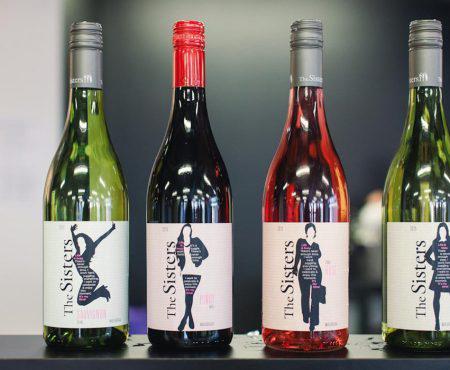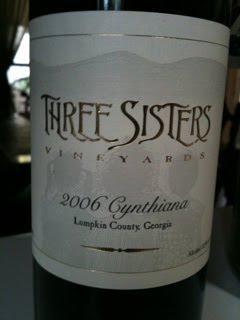The first image is the image on the left, the second image is the image on the right. Given the left and right images, does the statement "Left image shows at least four wine bottles of various colors, arranged in a horizontal row." hold true? Answer yes or no. Yes. The first image is the image on the left, the second image is the image on the right. Evaluate the accuracy of this statement regarding the images: "There is a row of wine bottles with multiple colors". Is it true? Answer yes or no. Yes. 